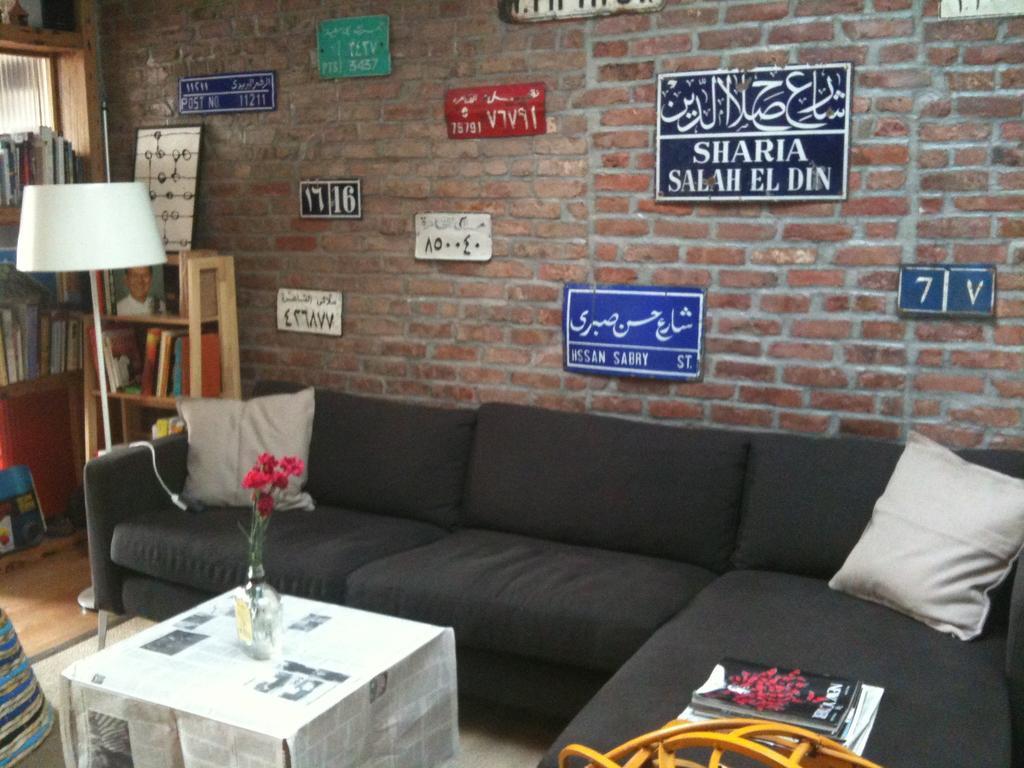Could you give a brief overview of what you see in this image? Here you can see a black color sofa and a white color pillows on it. In front of the sofa there is a table and a flower vase on it. To the left corner there is a book cupboard. We can also see a lamp. And we can see a brick wall and some posters on it. You can see some books on sofa. 